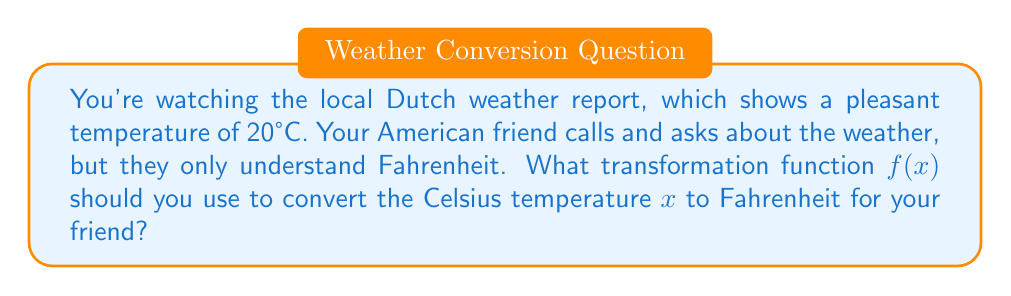Can you solve this math problem? Let's approach this step-by-step:

1) The general formula to convert Celsius to Fahrenheit is:
   $F = \frac{9}{5}C + 32$

2) In this case, we want to create a function $f(x)$ where $x$ is the temperature in Celsius:
   $f(x) = \frac{9}{5}x + 32$

3) This function represents a linear transformation of the input $x$:
   - The term $\frac{9}{5}x$ represents a scaling of the input by a factor of $\frac{9}{5}$
   - The addition of 32 represents a vertical shift upwards by 32 units

4) We can break down this transformation into two steps:
   a) Multiply the input by $\frac{9}{5}$: $g(x) = \frac{9}{5}x$
   b) Add 32 to the result: $f(x) = g(x) + 32$

5) Therefore, the complete transformation function is:
   $f(x) = \frac{9}{5}x + 32$

This function will convert any Celsius temperature $x$ to its equivalent in Fahrenheit.
Answer: $f(x) = \frac{9}{5}x + 32$ 